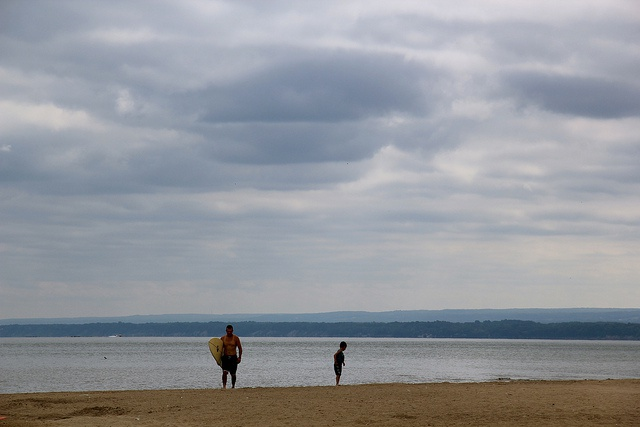Describe the objects in this image and their specific colors. I can see people in gray, black, maroon, and darkgray tones, people in gray, black, darkgray, and maroon tones, and surfboard in gray, olive, black, and maroon tones in this image. 